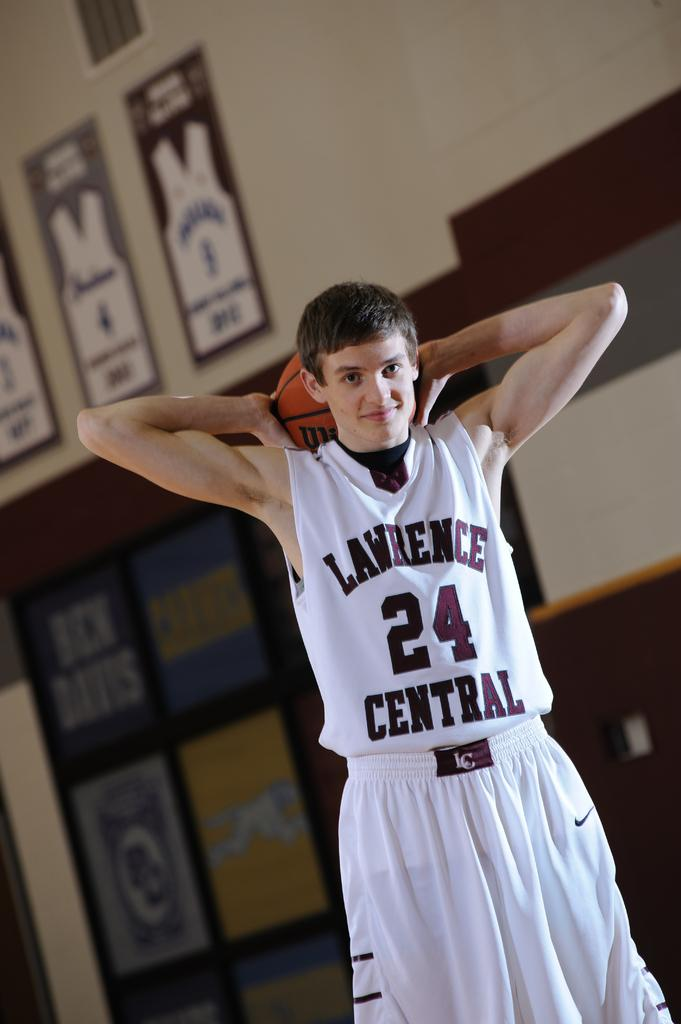What is the main subject of the image? There is a person in the image. What is the person holding in the image? The person is holding a ball. What can be seen in the background of the image? There is a wall in the background of the image. What is on the wall in the image? The wall has photo frames on it. Can you tell me the order number of the receipt in the image? There is no receipt present in the image. What type of fruit is being used to decorate the wall in the image? There is no fruit, including quince, being used to decorate the wall in the image. 